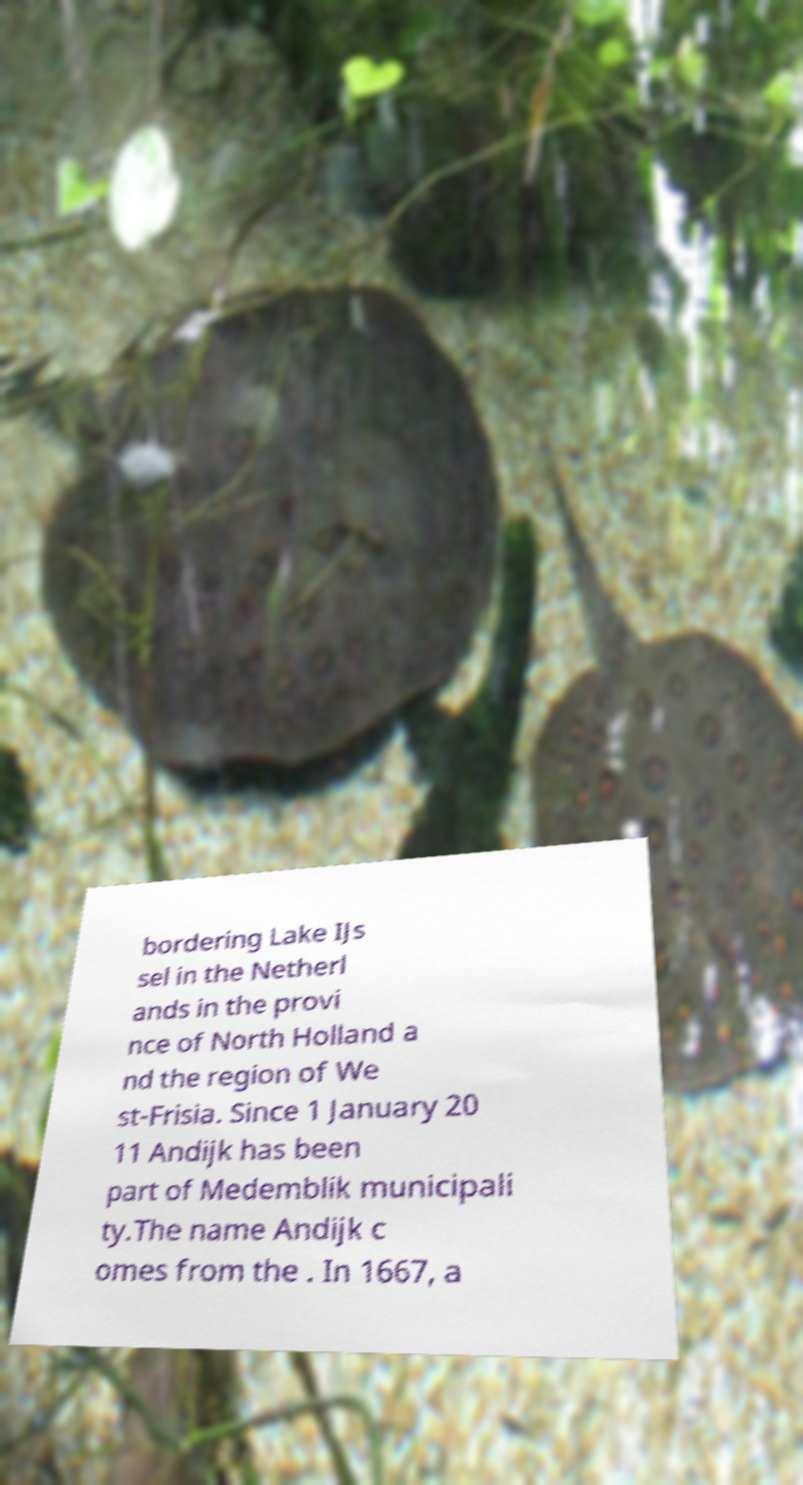Could you extract and type out the text from this image? bordering Lake IJs sel in the Netherl ands in the provi nce of North Holland a nd the region of We st-Frisia. Since 1 January 20 11 Andijk has been part of Medemblik municipali ty.The name Andijk c omes from the . In 1667, a 